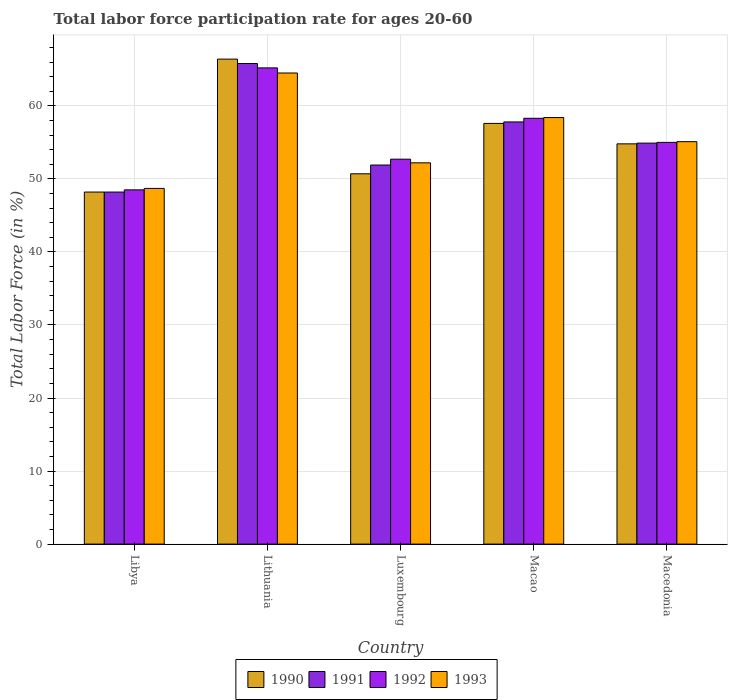How many groups of bars are there?
Provide a short and direct response. 5. Are the number of bars on each tick of the X-axis equal?
Provide a short and direct response. Yes. How many bars are there on the 2nd tick from the right?
Keep it short and to the point. 4. What is the label of the 1st group of bars from the left?
Provide a short and direct response. Libya. What is the labor force participation rate in 1992 in Macao?
Provide a succinct answer. 58.3. Across all countries, what is the maximum labor force participation rate in 1993?
Keep it short and to the point. 64.5. Across all countries, what is the minimum labor force participation rate in 1991?
Provide a succinct answer. 48.2. In which country was the labor force participation rate in 1992 maximum?
Keep it short and to the point. Lithuania. In which country was the labor force participation rate in 1990 minimum?
Offer a terse response. Libya. What is the total labor force participation rate in 1992 in the graph?
Provide a succinct answer. 279.7. What is the difference between the labor force participation rate in 1990 in Libya and that in Macao?
Your answer should be compact. -9.4. What is the difference between the labor force participation rate in 1993 in Luxembourg and the labor force participation rate in 1990 in Lithuania?
Provide a short and direct response. -14.2. What is the average labor force participation rate in 1990 per country?
Your answer should be very brief. 55.54. What is the difference between the labor force participation rate of/in 1992 and labor force participation rate of/in 1993 in Macao?
Offer a terse response. -0.1. In how many countries, is the labor force participation rate in 1993 greater than 38 %?
Ensure brevity in your answer.  5. What is the ratio of the labor force participation rate in 1993 in Libya to that in Lithuania?
Offer a very short reply. 0.76. Is the labor force participation rate in 1991 in Luxembourg less than that in Macao?
Give a very brief answer. Yes. Is the difference between the labor force participation rate in 1992 in Libya and Lithuania greater than the difference between the labor force participation rate in 1993 in Libya and Lithuania?
Make the answer very short. No. What is the difference between the highest and the second highest labor force participation rate in 1992?
Keep it short and to the point. 6.9. What is the difference between the highest and the lowest labor force participation rate in 1991?
Give a very brief answer. 17.6. What does the 3rd bar from the left in Lithuania represents?
Keep it short and to the point. 1992. Is it the case that in every country, the sum of the labor force participation rate in 1992 and labor force participation rate in 1993 is greater than the labor force participation rate in 1990?
Make the answer very short. Yes. How many bars are there?
Provide a short and direct response. 20. Does the graph contain any zero values?
Offer a very short reply. No. Where does the legend appear in the graph?
Ensure brevity in your answer.  Bottom center. How are the legend labels stacked?
Offer a very short reply. Horizontal. What is the title of the graph?
Keep it short and to the point. Total labor force participation rate for ages 20-60. Does "1982" appear as one of the legend labels in the graph?
Offer a very short reply. No. What is the Total Labor Force (in %) of 1990 in Libya?
Provide a short and direct response. 48.2. What is the Total Labor Force (in %) of 1991 in Libya?
Offer a terse response. 48.2. What is the Total Labor Force (in %) in 1992 in Libya?
Your answer should be compact. 48.5. What is the Total Labor Force (in %) of 1993 in Libya?
Give a very brief answer. 48.7. What is the Total Labor Force (in %) in 1990 in Lithuania?
Your answer should be very brief. 66.4. What is the Total Labor Force (in %) in 1991 in Lithuania?
Your answer should be compact. 65.8. What is the Total Labor Force (in %) in 1992 in Lithuania?
Offer a terse response. 65.2. What is the Total Labor Force (in %) in 1993 in Lithuania?
Your answer should be compact. 64.5. What is the Total Labor Force (in %) in 1990 in Luxembourg?
Offer a very short reply. 50.7. What is the Total Labor Force (in %) in 1991 in Luxembourg?
Your answer should be compact. 51.9. What is the Total Labor Force (in %) in 1992 in Luxembourg?
Offer a very short reply. 52.7. What is the Total Labor Force (in %) in 1993 in Luxembourg?
Your answer should be compact. 52.2. What is the Total Labor Force (in %) in 1990 in Macao?
Your answer should be very brief. 57.6. What is the Total Labor Force (in %) in 1991 in Macao?
Make the answer very short. 57.8. What is the Total Labor Force (in %) in 1992 in Macao?
Offer a terse response. 58.3. What is the Total Labor Force (in %) in 1993 in Macao?
Your answer should be very brief. 58.4. What is the Total Labor Force (in %) in 1990 in Macedonia?
Ensure brevity in your answer.  54.8. What is the Total Labor Force (in %) in 1991 in Macedonia?
Offer a terse response. 54.9. What is the Total Labor Force (in %) in 1992 in Macedonia?
Provide a short and direct response. 55. What is the Total Labor Force (in %) in 1993 in Macedonia?
Provide a succinct answer. 55.1. Across all countries, what is the maximum Total Labor Force (in %) of 1990?
Offer a very short reply. 66.4. Across all countries, what is the maximum Total Labor Force (in %) in 1991?
Keep it short and to the point. 65.8. Across all countries, what is the maximum Total Labor Force (in %) of 1992?
Offer a very short reply. 65.2. Across all countries, what is the maximum Total Labor Force (in %) in 1993?
Make the answer very short. 64.5. Across all countries, what is the minimum Total Labor Force (in %) in 1990?
Provide a short and direct response. 48.2. Across all countries, what is the minimum Total Labor Force (in %) of 1991?
Provide a succinct answer. 48.2. Across all countries, what is the minimum Total Labor Force (in %) in 1992?
Keep it short and to the point. 48.5. Across all countries, what is the minimum Total Labor Force (in %) of 1993?
Your response must be concise. 48.7. What is the total Total Labor Force (in %) of 1990 in the graph?
Your response must be concise. 277.7. What is the total Total Labor Force (in %) in 1991 in the graph?
Offer a terse response. 278.6. What is the total Total Labor Force (in %) of 1992 in the graph?
Your response must be concise. 279.7. What is the total Total Labor Force (in %) in 1993 in the graph?
Your answer should be very brief. 278.9. What is the difference between the Total Labor Force (in %) in 1990 in Libya and that in Lithuania?
Your answer should be compact. -18.2. What is the difference between the Total Labor Force (in %) in 1991 in Libya and that in Lithuania?
Make the answer very short. -17.6. What is the difference between the Total Labor Force (in %) in 1992 in Libya and that in Lithuania?
Offer a terse response. -16.7. What is the difference between the Total Labor Force (in %) in 1993 in Libya and that in Lithuania?
Ensure brevity in your answer.  -15.8. What is the difference between the Total Labor Force (in %) of 1991 in Libya and that in Macao?
Keep it short and to the point. -9.6. What is the difference between the Total Labor Force (in %) of 1992 in Libya and that in Macao?
Offer a very short reply. -9.8. What is the difference between the Total Labor Force (in %) of 1990 in Lithuania and that in Luxembourg?
Provide a succinct answer. 15.7. What is the difference between the Total Labor Force (in %) of 1992 in Lithuania and that in Luxembourg?
Provide a short and direct response. 12.5. What is the difference between the Total Labor Force (in %) in 1993 in Lithuania and that in Luxembourg?
Offer a very short reply. 12.3. What is the difference between the Total Labor Force (in %) of 1991 in Lithuania and that in Macao?
Ensure brevity in your answer.  8. What is the difference between the Total Labor Force (in %) in 1991 in Lithuania and that in Macedonia?
Provide a short and direct response. 10.9. What is the difference between the Total Labor Force (in %) in 1992 in Lithuania and that in Macedonia?
Provide a succinct answer. 10.2. What is the difference between the Total Labor Force (in %) in 1993 in Luxembourg and that in Macao?
Your answer should be very brief. -6.2. What is the difference between the Total Labor Force (in %) in 1990 in Luxembourg and that in Macedonia?
Keep it short and to the point. -4.1. What is the difference between the Total Labor Force (in %) in 1993 in Macao and that in Macedonia?
Offer a very short reply. 3.3. What is the difference between the Total Labor Force (in %) in 1990 in Libya and the Total Labor Force (in %) in 1991 in Lithuania?
Provide a succinct answer. -17.6. What is the difference between the Total Labor Force (in %) in 1990 in Libya and the Total Labor Force (in %) in 1993 in Lithuania?
Give a very brief answer. -16.3. What is the difference between the Total Labor Force (in %) of 1991 in Libya and the Total Labor Force (in %) of 1993 in Lithuania?
Your response must be concise. -16.3. What is the difference between the Total Labor Force (in %) in 1990 in Libya and the Total Labor Force (in %) in 1992 in Luxembourg?
Offer a very short reply. -4.5. What is the difference between the Total Labor Force (in %) of 1991 in Libya and the Total Labor Force (in %) of 1992 in Luxembourg?
Your answer should be very brief. -4.5. What is the difference between the Total Labor Force (in %) in 1992 in Libya and the Total Labor Force (in %) in 1993 in Luxembourg?
Give a very brief answer. -3.7. What is the difference between the Total Labor Force (in %) in 1990 in Libya and the Total Labor Force (in %) in 1993 in Macao?
Give a very brief answer. -10.2. What is the difference between the Total Labor Force (in %) in 1991 in Libya and the Total Labor Force (in %) in 1992 in Macao?
Your answer should be compact. -10.1. What is the difference between the Total Labor Force (in %) of 1990 in Libya and the Total Labor Force (in %) of 1991 in Macedonia?
Provide a succinct answer. -6.7. What is the difference between the Total Labor Force (in %) of 1990 in Libya and the Total Labor Force (in %) of 1992 in Macedonia?
Your answer should be very brief. -6.8. What is the difference between the Total Labor Force (in %) of 1990 in Libya and the Total Labor Force (in %) of 1993 in Macedonia?
Ensure brevity in your answer.  -6.9. What is the difference between the Total Labor Force (in %) of 1992 in Libya and the Total Labor Force (in %) of 1993 in Macedonia?
Make the answer very short. -6.6. What is the difference between the Total Labor Force (in %) of 1990 in Lithuania and the Total Labor Force (in %) of 1992 in Luxembourg?
Your answer should be very brief. 13.7. What is the difference between the Total Labor Force (in %) of 1990 in Lithuania and the Total Labor Force (in %) of 1993 in Luxembourg?
Make the answer very short. 14.2. What is the difference between the Total Labor Force (in %) of 1991 in Lithuania and the Total Labor Force (in %) of 1992 in Luxembourg?
Your answer should be compact. 13.1. What is the difference between the Total Labor Force (in %) in 1992 in Lithuania and the Total Labor Force (in %) in 1993 in Luxembourg?
Give a very brief answer. 13. What is the difference between the Total Labor Force (in %) of 1990 in Lithuania and the Total Labor Force (in %) of 1991 in Macao?
Make the answer very short. 8.6. What is the difference between the Total Labor Force (in %) in 1990 in Lithuania and the Total Labor Force (in %) in 1992 in Macao?
Offer a very short reply. 8.1. What is the difference between the Total Labor Force (in %) of 1990 in Lithuania and the Total Labor Force (in %) of 1993 in Macao?
Give a very brief answer. 8. What is the difference between the Total Labor Force (in %) in 1990 in Lithuania and the Total Labor Force (in %) in 1992 in Macedonia?
Give a very brief answer. 11.4. What is the difference between the Total Labor Force (in %) in 1990 in Lithuania and the Total Labor Force (in %) in 1993 in Macedonia?
Keep it short and to the point. 11.3. What is the difference between the Total Labor Force (in %) in 1992 in Lithuania and the Total Labor Force (in %) in 1993 in Macedonia?
Make the answer very short. 10.1. What is the difference between the Total Labor Force (in %) in 1991 in Luxembourg and the Total Labor Force (in %) in 1993 in Macao?
Give a very brief answer. -6.5. What is the difference between the Total Labor Force (in %) of 1992 in Luxembourg and the Total Labor Force (in %) of 1993 in Macao?
Ensure brevity in your answer.  -5.7. What is the difference between the Total Labor Force (in %) of 1990 in Luxembourg and the Total Labor Force (in %) of 1991 in Macedonia?
Keep it short and to the point. -4.2. What is the difference between the Total Labor Force (in %) in 1990 in Luxembourg and the Total Labor Force (in %) in 1992 in Macedonia?
Offer a very short reply. -4.3. What is the difference between the Total Labor Force (in %) of 1992 in Luxembourg and the Total Labor Force (in %) of 1993 in Macedonia?
Ensure brevity in your answer.  -2.4. What is the difference between the Total Labor Force (in %) in 1990 in Macao and the Total Labor Force (in %) in 1991 in Macedonia?
Your answer should be very brief. 2.7. What is the difference between the Total Labor Force (in %) in 1990 in Macao and the Total Labor Force (in %) in 1992 in Macedonia?
Your answer should be compact. 2.6. What is the difference between the Total Labor Force (in %) of 1990 in Macao and the Total Labor Force (in %) of 1993 in Macedonia?
Offer a very short reply. 2.5. What is the difference between the Total Labor Force (in %) in 1991 in Macao and the Total Labor Force (in %) in 1992 in Macedonia?
Provide a short and direct response. 2.8. What is the average Total Labor Force (in %) of 1990 per country?
Your response must be concise. 55.54. What is the average Total Labor Force (in %) in 1991 per country?
Offer a terse response. 55.72. What is the average Total Labor Force (in %) of 1992 per country?
Offer a terse response. 55.94. What is the average Total Labor Force (in %) of 1993 per country?
Ensure brevity in your answer.  55.78. What is the difference between the Total Labor Force (in %) of 1991 and Total Labor Force (in %) of 1992 in Libya?
Keep it short and to the point. -0.3. What is the difference between the Total Labor Force (in %) of 1991 and Total Labor Force (in %) of 1993 in Libya?
Your answer should be compact. -0.5. What is the difference between the Total Labor Force (in %) in 1990 and Total Labor Force (in %) in 1991 in Lithuania?
Your response must be concise. 0.6. What is the difference between the Total Labor Force (in %) of 1990 and Total Labor Force (in %) of 1992 in Lithuania?
Keep it short and to the point. 1.2. What is the difference between the Total Labor Force (in %) in 1990 and Total Labor Force (in %) in 1993 in Luxembourg?
Make the answer very short. -1.5. What is the difference between the Total Labor Force (in %) in 1991 and Total Labor Force (in %) in 1992 in Luxembourg?
Offer a terse response. -0.8. What is the difference between the Total Labor Force (in %) in 1990 and Total Labor Force (in %) in 1992 in Macao?
Offer a very short reply. -0.7. What is the difference between the Total Labor Force (in %) of 1990 and Total Labor Force (in %) of 1992 in Macedonia?
Offer a terse response. -0.2. What is the difference between the Total Labor Force (in %) in 1991 and Total Labor Force (in %) in 1992 in Macedonia?
Ensure brevity in your answer.  -0.1. What is the difference between the Total Labor Force (in %) of 1991 and Total Labor Force (in %) of 1993 in Macedonia?
Offer a very short reply. -0.2. What is the ratio of the Total Labor Force (in %) in 1990 in Libya to that in Lithuania?
Offer a very short reply. 0.73. What is the ratio of the Total Labor Force (in %) in 1991 in Libya to that in Lithuania?
Provide a succinct answer. 0.73. What is the ratio of the Total Labor Force (in %) in 1992 in Libya to that in Lithuania?
Offer a terse response. 0.74. What is the ratio of the Total Labor Force (in %) in 1993 in Libya to that in Lithuania?
Keep it short and to the point. 0.76. What is the ratio of the Total Labor Force (in %) in 1990 in Libya to that in Luxembourg?
Your response must be concise. 0.95. What is the ratio of the Total Labor Force (in %) of 1991 in Libya to that in Luxembourg?
Offer a terse response. 0.93. What is the ratio of the Total Labor Force (in %) in 1992 in Libya to that in Luxembourg?
Provide a succinct answer. 0.92. What is the ratio of the Total Labor Force (in %) in 1993 in Libya to that in Luxembourg?
Your answer should be very brief. 0.93. What is the ratio of the Total Labor Force (in %) of 1990 in Libya to that in Macao?
Offer a terse response. 0.84. What is the ratio of the Total Labor Force (in %) of 1991 in Libya to that in Macao?
Provide a succinct answer. 0.83. What is the ratio of the Total Labor Force (in %) of 1992 in Libya to that in Macao?
Offer a very short reply. 0.83. What is the ratio of the Total Labor Force (in %) in 1993 in Libya to that in Macao?
Give a very brief answer. 0.83. What is the ratio of the Total Labor Force (in %) in 1990 in Libya to that in Macedonia?
Your answer should be compact. 0.88. What is the ratio of the Total Labor Force (in %) in 1991 in Libya to that in Macedonia?
Ensure brevity in your answer.  0.88. What is the ratio of the Total Labor Force (in %) in 1992 in Libya to that in Macedonia?
Make the answer very short. 0.88. What is the ratio of the Total Labor Force (in %) in 1993 in Libya to that in Macedonia?
Keep it short and to the point. 0.88. What is the ratio of the Total Labor Force (in %) of 1990 in Lithuania to that in Luxembourg?
Your response must be concise. 1.31. What is the ratio of the Total Labor Force (in %) of 1991 in Lithuania to that in Luxembourg?
Provide a succinct answer. 1.27. What is the ratio of the Total Labor Force (in %) of 1992 in Lithuania to that in Luxembourg?
Your answer should be compact. 1.24. What is the ratio of the Total Labor Force (in %) in 1993 in Lithuania to that in Luxembourg?
Make the answer very short. 1.24. What is the ratio of the Total Labor Force (in %) in 1990 in Lithuania to that in Macao?
Keep it short and to the point. 1.15. What is the ratio of the Total Labor Force (in %) in 1991 in Lithuania to that in Macao?
Offer a terse response. 1.14. What is the ratio of the Total Labor Force (in %) in 1992 in Lithuania to that in Macao?
Provide a succinct answer. 1.12. What is the ratio of the Total Labor Force (in %) in 1993 in Lithuania to that in Macao?
Keep it short and to the point. 1.1. What is the ratio of the Total Labor Force (in %) of 1990 in Lithuania to that in Macedonia?
Your response must be concise. 1.21. What is the ratio of the Total Labor Force (in %) of 1991 in Lithuania to that in Macedonia?
Offer a terse response. 1.2. What is the ratio of the Total Labor Force (in %) in 1992 in Lithuania to that in Macedonia?
Provide a short and direct response. 1.19. What is the ratio of the Total Labor Force (in %) in 1993 in Lithuania to that in Macedonia?
Your response must be concise. 1.17. What is the ratio of the Total Labor Force (in %) in 1990 in Luxembourg to that in Macao?
Your answer should be compact. 0.88. What is the ratio of the Total Labor Force (in %) in 1991 in Luxembourg to that in Macao?
Your answer should be compact. 0.9. What is the ratio of the Total Labor Force (in %) of 1992 in Luxembourg to that in Macao?
Offer a very short reply. 0.9. What is the ratio of the Total Labor Force (in %) of 1993 in Luxembourg to that in Macao?
Offer a terse response. 0.89. What is the ratio of the Total Labor Force (in %) in 1990 in Luxembourg to that in Macedonia?
Your response must be concise. 0.93. What is the ratio of the Total Labor Force (in %) of 1991 in Luxembourg to that in Macedonia?
Offer a terse response. 0.95. What is the ratio of the Total Labor Force (in %) of 1992 in Luxembourg to that in Macedonia?
Your answer should be very brief. 0.96. What is the ratio of the Total Labor Force (in %) in 1990 in Macao to that in Macedonia?
Provide a succinct answer. 1.05. What is the ratio of the Total Labor Force (in %) in 1991 in Macao to that in Macedonia?
Provide a succinct answer. 1.05. What is the ratio of the Total Labor Force (in %) in 1992 in Macao to that in Macedonia?
Make the answer very short. 1.06. What is the ratio of the Total Labor Force (in %) in 1993 in Macao to that in Macedonia?
Your answer should be compact. 1.06. What is the difference between the highest and the lowest Total Labor Force (in %) in 1991?
Give a very brief answer. 17.6. What is the difference between the highest and the lowest Total Labor Force (in %) of 1992?
Provide a succinct answer. 16.7. 